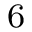<formula> <loc_0><loc_0><loc_500><loc_500>^ { 6 }</formula> 